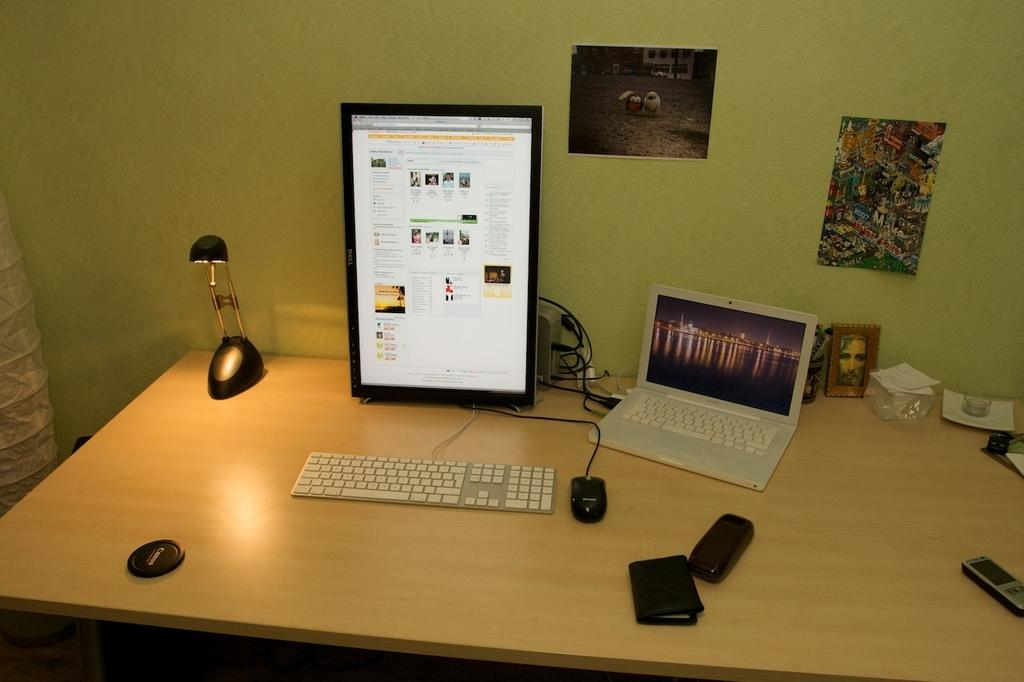What electronic devices can be seen in the image? There is a computer and a laptop in the image. What else is present on the table in the image? There is a wallet on the table in the image. What can be seen on the wall in the image? There are posters on the wall in the image. What type of advertisement is being displayed on the computer screen in the image? There is no advertisement visible on the computer screen in the image. 